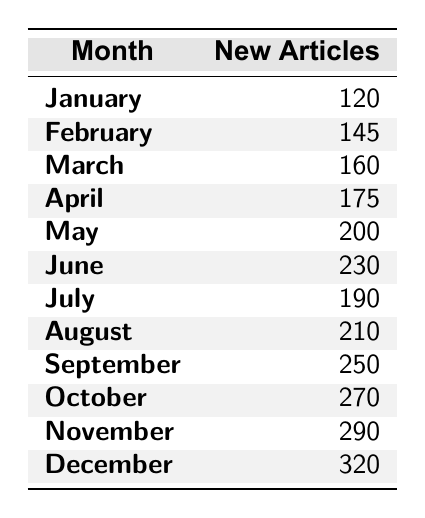What is the total number of new articles added in December? The table states that in December, there were 320 new articles added.
Answer: 320 Which month had the highest number of new articles? December had the highest number of new articles at 320, as seen in the last row of the table.
Answer: December How many new articles were added in June? According to the table, June had 230 new articles added.
Answer: 230 What is the average number of new articles added from January to June? The total number of articles from January to June is 120 + 145 + 160 + 175 + 200 + 230 = 1,030. There are 6 months, so the average is 1,030 / 6 = approximately 171.67.
Answer: 171.67 How many new articles were added in the second half of the year (July to December)? Adding the values from July to December, we have 190 + 210 + 250 + 270 + 290 + 320 = 1,530 new articles.
Answer: 1530 Was there an increase in new articles from March to April? Yes, there was an increase; March had 160 new articles, while April had 175, which is an increase of 15.
Answer: Yes What is the difference in the number of new articles added between February and October? February had 145 new articles and October had 270, so the difference is 270 - 145 = 125 new articles.
Answer: 125 Which months saw an increase in new articles compared to the previous month? The months with increases are February (145 - 120), March (160 - 145), April (175 - 160), May (200 - 175), June (230 - 200), August (210 - 190), September (250 - 210), October (270 - 250), November (290 - 270), and December (320 - 290).
Answer: 10 months What was the percentage growth of new articles from January to December? January had 120 and December had 320. The growth is (320 - 120)/120 * 100 = 166.67%.
Answer: 166.67% If we consider the total new articles added for the entire year, what was that amount? Adding all new articles together gives 120 + 145 + 160 + 175 + 200 + 230 + 190 + 210 + 250 + 270 + 290 + 320 = 2,555.
Answer: 2555 